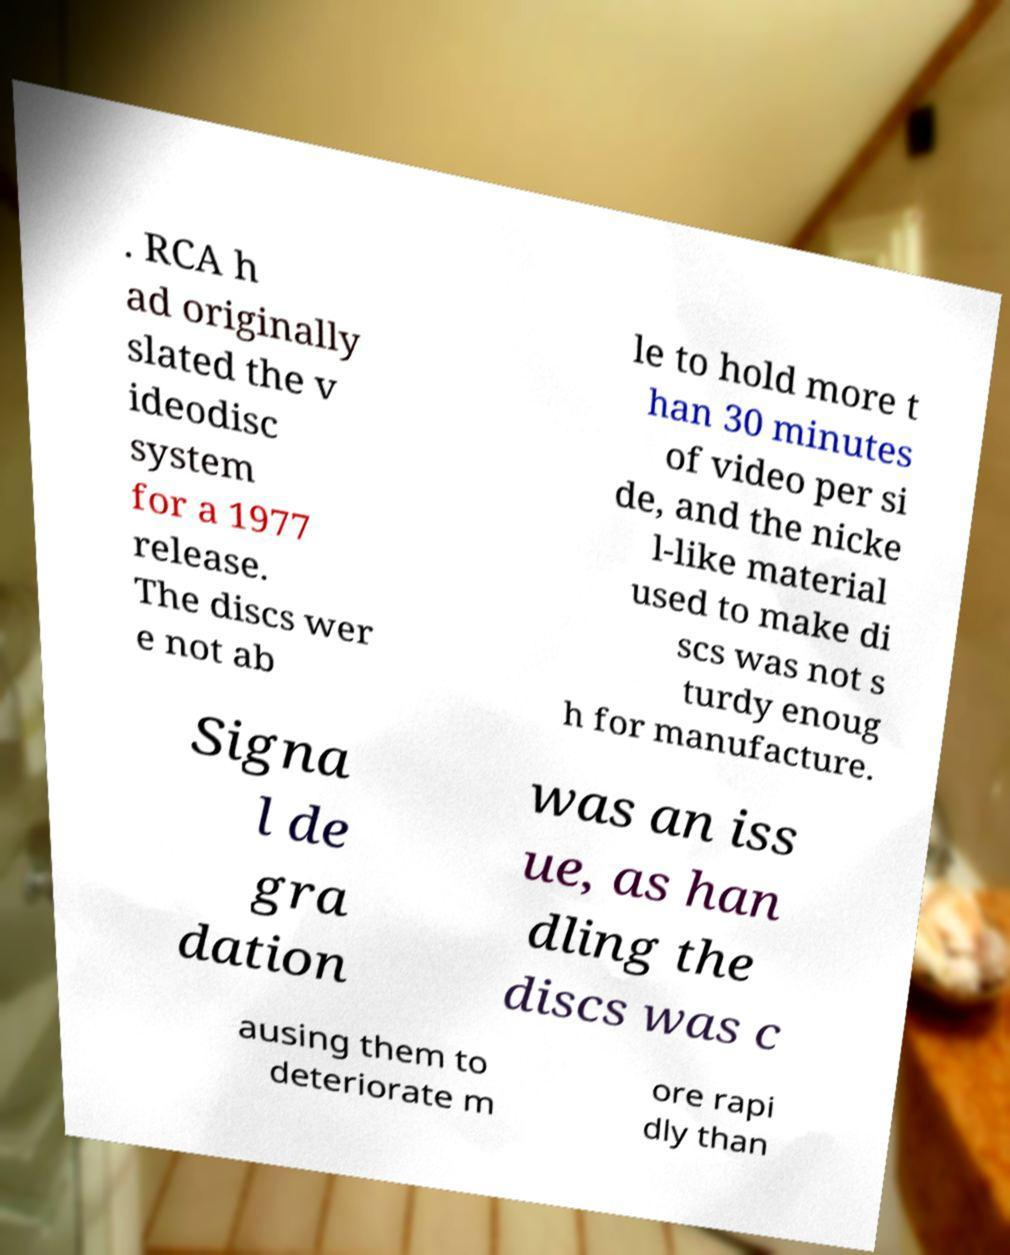I need the written content from this picture converted into text. Can you do that? . RCA h ad originally slated the v ideodisc system for a 1977 release. The discs wer e not ab le to hold more t han 30 minutes of video per si de, and the nicke l-like material used to make di scs was not s turdy enoug h for manufacture. Signa l de gra dation was an iss ue, as han dling the discs was c ausing them to deteriorate m ore rapi dly than 